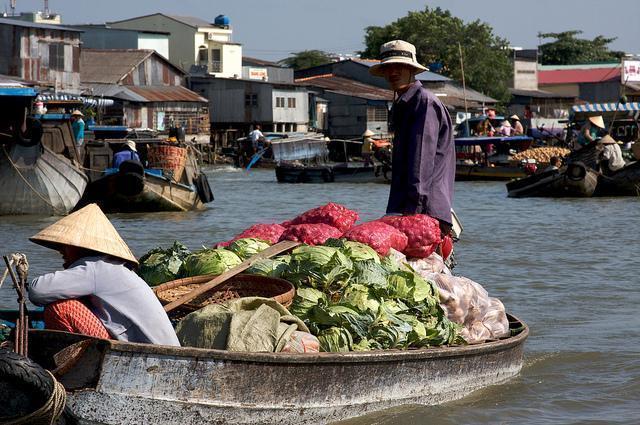What kind of boat is this?
Select the accurate response from the four choices given to answer the question.
Options: Tow boat, fishing, transport, coast guard. Transport. 